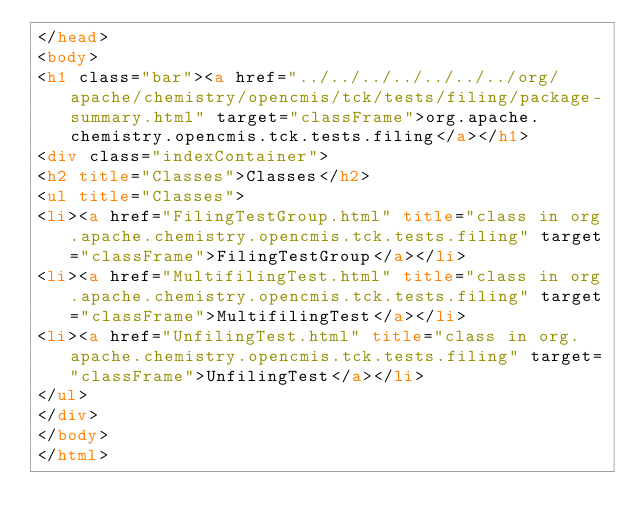Convert code to text. <code><loc_0><loc_0><loc_500><loc_500><_HTML_></head>
<body>
<h1 class="bar"><a href="../../../../../../../org/apache/chemistry/opencmis/tck/tests/filing/package-summary.html" target="classFrame">org.apache.chemistry.opencmis.tck.tests.filing</a></h1>
<div class="indexContainer">
<h2 title="Classes">Classes</h2>
<ul title="Classes">
<li><a href="FilingTestGroup.html" title="class in org.apache.chemistry.opencmis.tck.tests.filing" target="classFrame">FilingTestGroup</a></li>
<li><a href="MultifilingTest.html" title="class in org.apache.chemistry.opencmis.tck.tests.filing" target="classFrame">MultifilingTest</a></li>
<li><a href="UnfilingTest.html" title="class in org.apache.chemistry.opencmis.tck.tests.filing" target="classFrame">UnfilingTest</a></li>
</ul>
</div>
</body>
</html>
</code> 